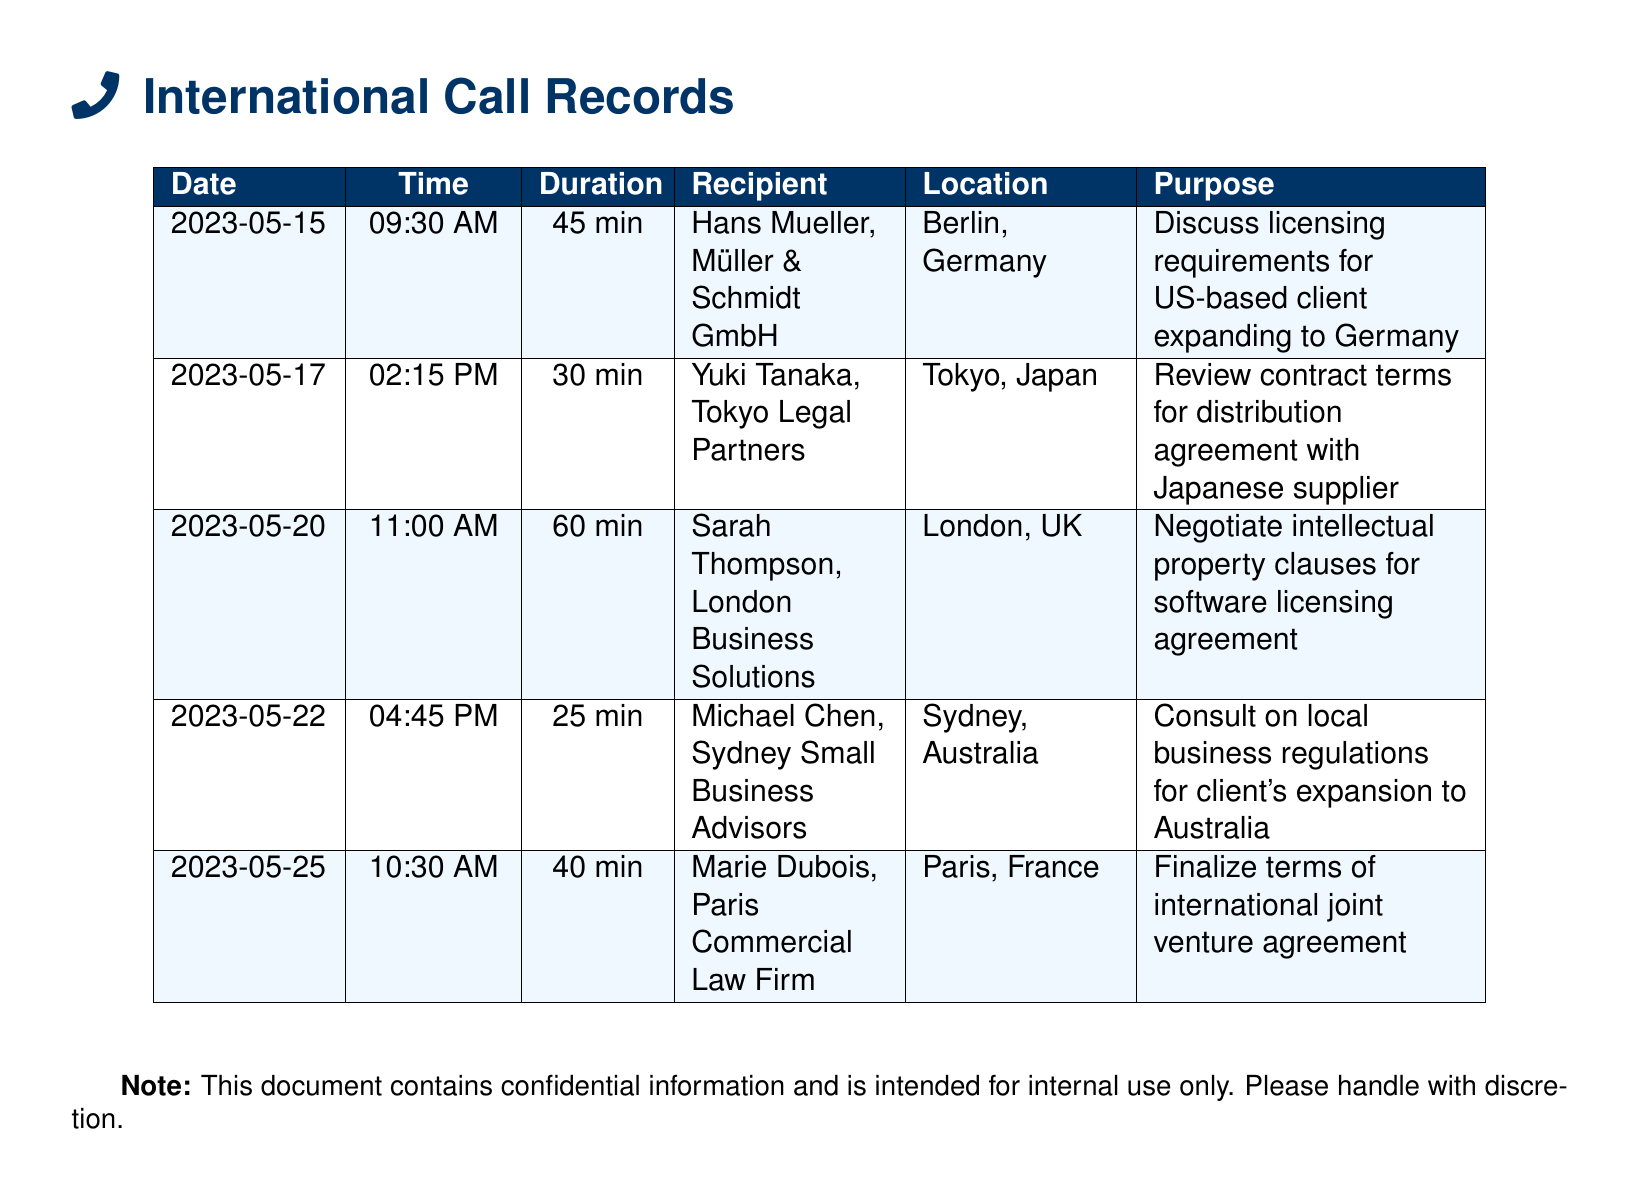What is the date of the call with Hans Mueller? The date of the call is listed in the document specifically for Hans Mueller, which is May 15, 2023.
Answer: May 15, 2023 How long was the call with Yuki Tanaka? The duration of the call with Yuki Tanaka is indicated as 30 minutes in the records.
Answer: 30 min What is the purpose of the call with Marie Dubois? The document specifies that the purpose of the call is to finalize terms of an international joint venture agreement.
Answer: Finalize terms of international joint venture agreement Which location is associated with the call to Michael Chen? The location associated with the call to Michael Chen is listed in the document as Sydney, Australia.
Answer: Sydney, Australia Which call had the longest duration? By comparing the call durations listed in the document, the call with Sarah Thompson lasted the longest at 60 minutes.
Answer: 60 min What is the name of the recipient in the call made on May 22? The recipient of the call made on May 22 is clearly stated in the document as Michael Chen.
Answer: Michael Chen How many calls were made to overseas business partners in total? The document provides a summary of five records of calls made, indicating the total count of phone calls.
Answer: 5 What type of agreement was discussed during the call with Yuki Tanaka? The document specifies that the agreement discussed was related to a distribution agreement with a Japanese supplier.
Answer: Distribution agreement What time was the call with Sarah Thompson? The time of the call with Sarah Thompson is specified as 11:00 AM in the document.
Answer: 11:00 AM 